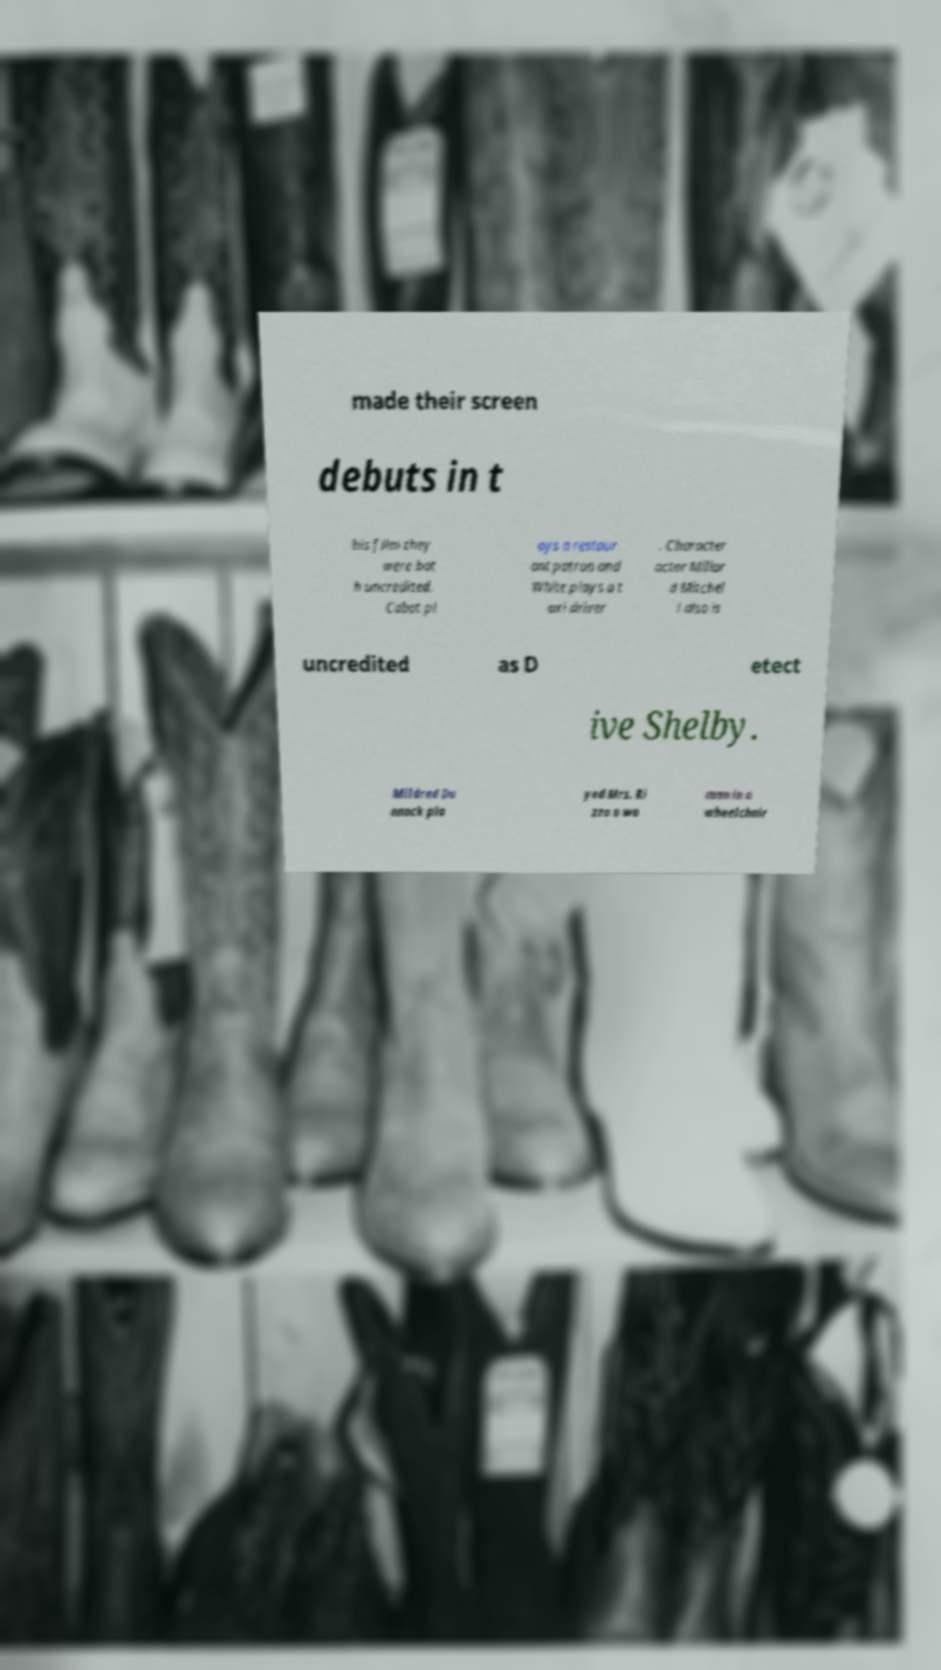There's text embedded in this image that I need extracted. Can you transcribe it verbatim? made their screen debuts in t his film they were bot h uncredited. Cabot pl ays a restaur ant patron and White plays a t axi driver . Character actor Millar d Mitchel l also is uncredited as D etect ive Shelby. Mildred Du nnock pla yed Mrs. Ri zzo a wo man in a wheelchair 